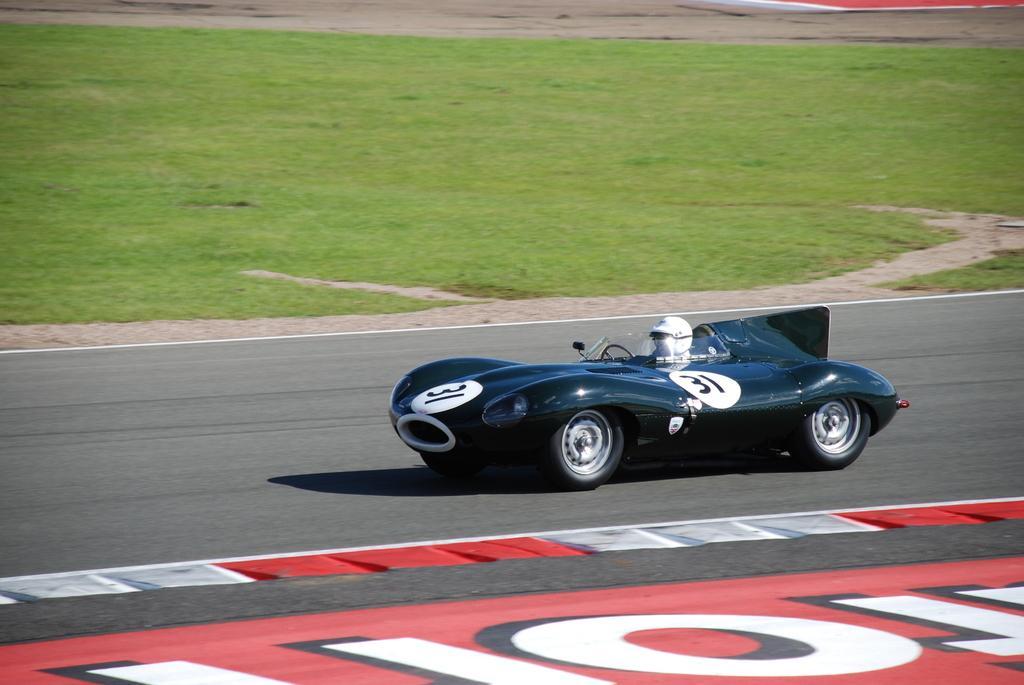Could you give a brief overview of what you see in this image? As we can see there is a grass, a man sitting on blue color car and the car is on road. 